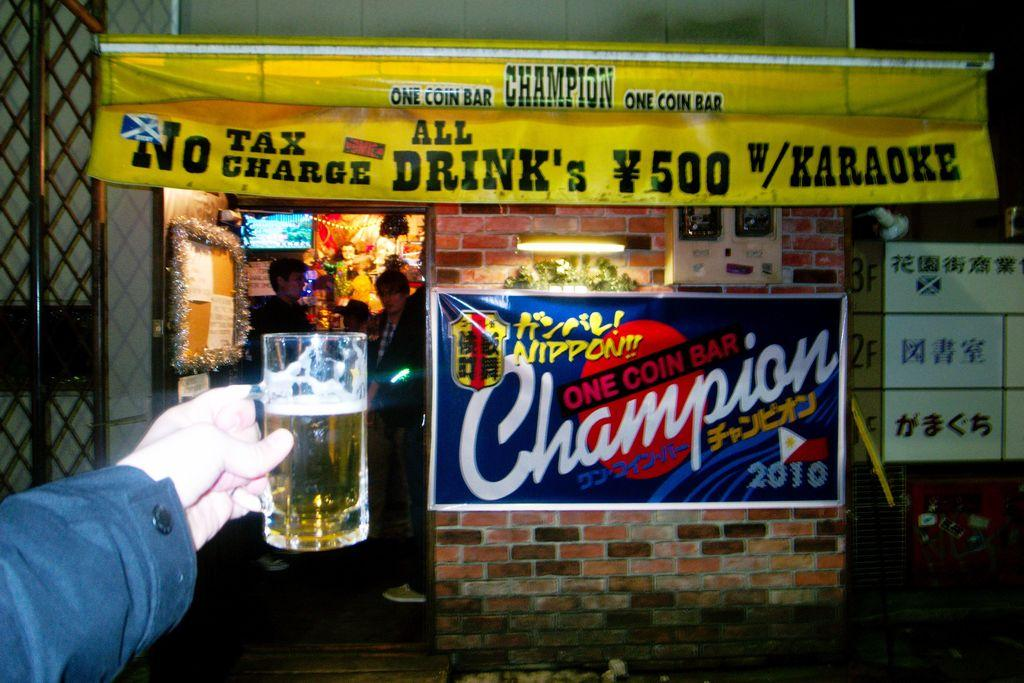<image>
Write a terse but informative summary of the picture. Someone holds a beer up to a sign for Champion one coin bar. 